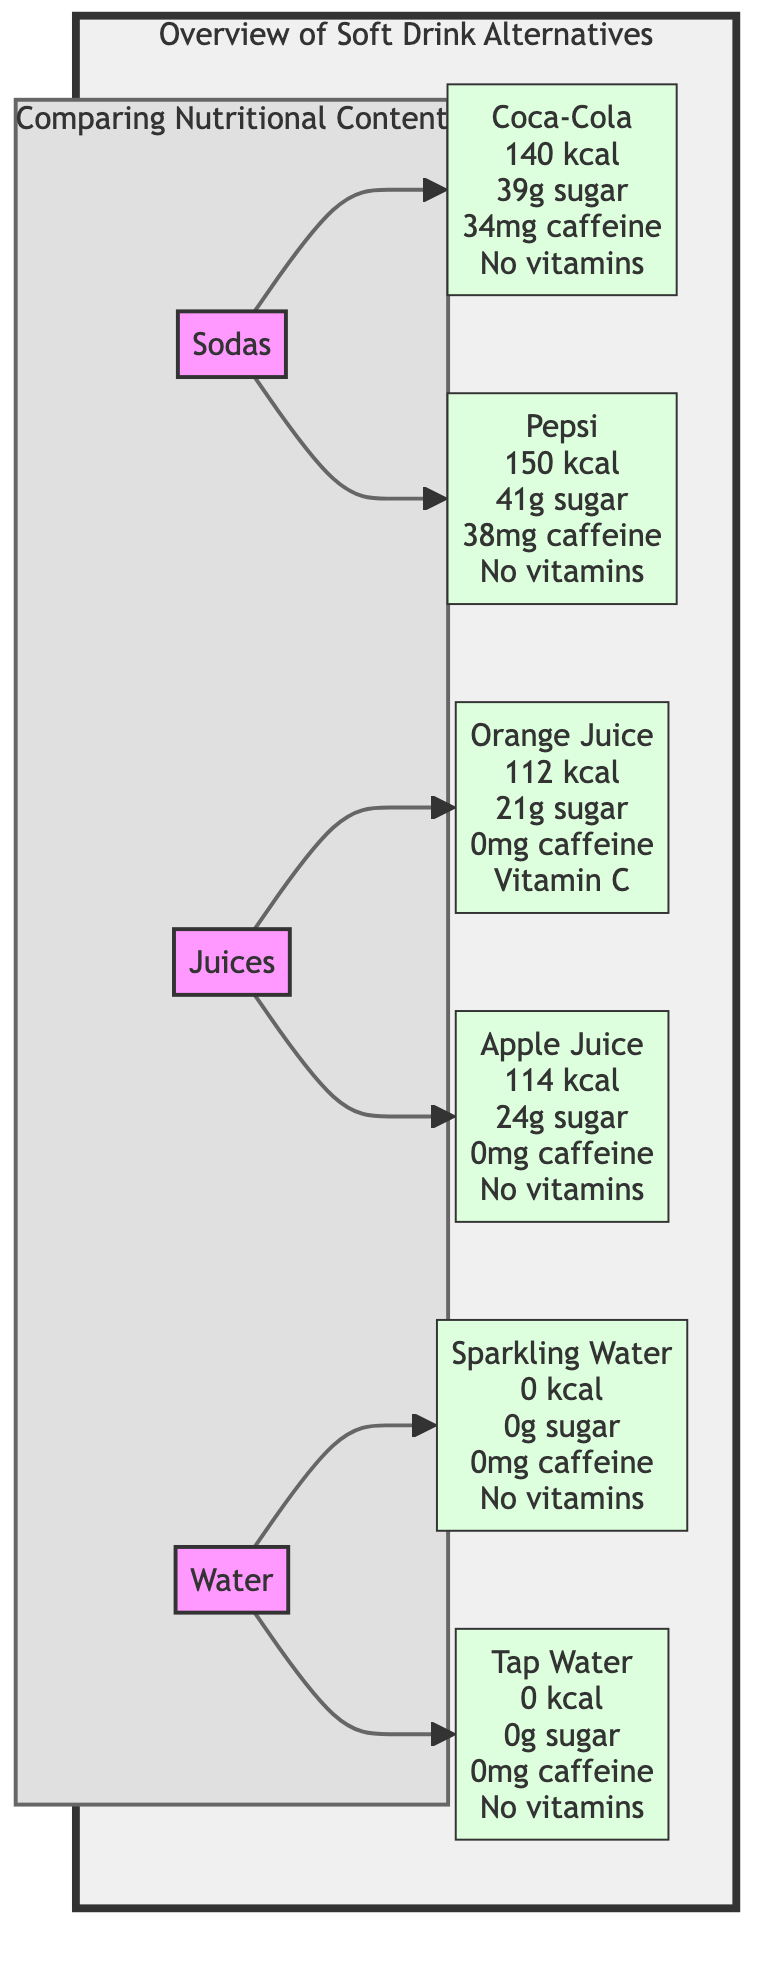What are the calories in Coca-Cola? The diagram shows a detail for Coca-Cola under the "Sodas" category, stating it has 140 kcal.
Answer: 140 kcal How much sugar is in Apple Juice? Looking at the "Juices" category, the Apple Juice node shows that it contains 24g of sugar.
Answer: 24g sugar Which drink category has no calories? The diagram indicates that both Sparkling Water and Tap Water, categorized under "Water," have 0 kcal, so Water is the category that has no calories.
Answer: Water What is the caffeine content of Orange Juice? The Orange Juice node within the "Juices" section clearly states it has 0mg caffeine, indicating that it does not contain any caffeine.
Answer: 0mg caffeine Which soda has more sugar, Coca-Cola or Pepsi? To compare the sugar content, Coca-Cola has 39g of sugar, while Pepsi has 41g of sugar, making Pepsi the one with more sugar.
Answer: Pepsi What is the vitamin content of Sparkling Water? The Sparkling Water node indicates "No vitamins," which implies it does not contain any vitamins.
Answer: No vitamins How many drinks are listed under the Juices category? The "Juices" category shows two nodes: Orange Juice and Apple Juice. Thus, there are two drinks listed under that category.
Answer: 2 Is there any caffeine in Tap Water? The Tap Water node specifies 0mg caffeine, indicating that there is no caffeine present in Tap Water.
Answer: 0mg caffeine What is the total number of drinks compared in the diagram? Counting all the drinks across the Sodas, Juices, and Water categories, there are 6 drinks total: 2 sodas, 2 juices, and 2 types of water.
Answer: 6 